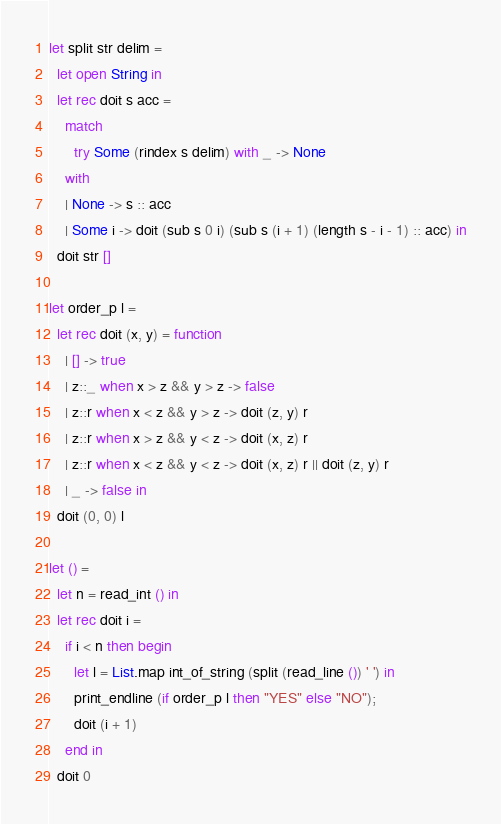Convert code to text. <code><loc_0><loc_0><loc_500><loc_500><_OCaml_>let split str delim =
  let open String in
  let rec doit s acc =
    match
      try Some (rindex s delim) with _ -> None
    with
    | None -> s :: acc
    | Some i -> doit (sub s 0 i) (sub s (i + 1) (length s - i - 1) :: acc) in
  doit str []

let order_p l =
  let rec doit (x, y) = function
    | [] -> true
    | z::_ when x > z && y > z -> false
    | z::r when x < z && y > z -> doit (z, y) r
    | z::r when x > z && y < z -> doit (x, z) r
    | z::r when x < z && y < z -> doit (x, z) r || doit (z, y) r
    | _ -> false in
  doit (0, 0) l

let () =
  let n = read_int () in
  let rec doit i =
    if i < n then begin
      let l = List.map int_of_string (split (read_line ()) ' ') in
      print_endline (if order_p l then "YES" else "NO");
      doit (i + 1)
    end in
  doit 0</code> 